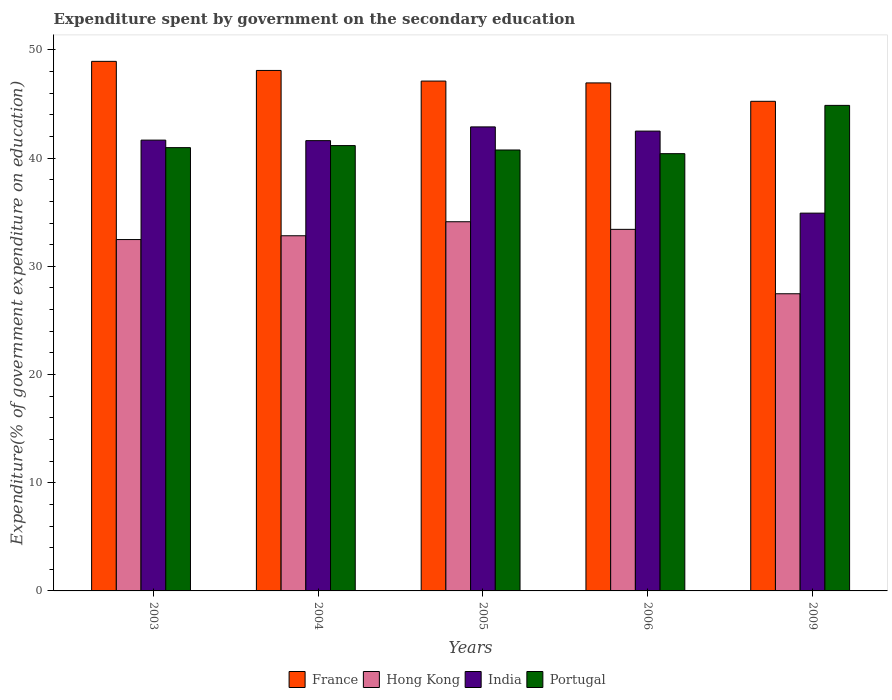Are the number of bars on each tick of the X-axis equal?
Your answer should be very brief. Yes. How many bars are there on the 5th tick from the right?
Your answer should be compact. 4. What is the expenditure spent by government on the secondary education in India in 2009?
Provide a succinct answer. 34.92. Across all years, what is the maximum expenditure spent by government on the secondary education in France?
Offer a very short reply. 48.95. Across all years, what is the minimum expenditure spent by government on the secondary education in India?
Provide a short and direct response. 34.92. In which year was the expenditure spent by government on the secondary education in Hong Kong minimum?
Provide a succinct answer. 2009. What is the total expenditure spent by government on the secondary education in France in the graph?
Your answer should be compact. 236.38. What is the difference between the expenditure spent by government on the secondary education in France in 2003 and that in 2004?
Keep it short and to the point. 0.84. What is the difference between the expenditure spent by government on the secondary education in France in 2003 and the expenditure spent by government on the secondary education in India in 2009?
Ensure brevity in your answer.  14.03. What is the average expenditure spent by government on the secondary education in Portugal per year?
Offer a terse response. 41.64. In the year 2006, what is the difference between the expenditure spent by government on the secondary education in Hong Kong and expenditure spent by government on the secondary education in Portugal?
Your answer should be very brief. -7. What is the ratio of the expenditure spent by government on the secondary education in Hong Kong in 2005 to that in 2006?
Your response must be concise. 1.02. Is the expenditure spent by government on the secondary education in France in 2005 less than that in 2009?
Offer a very short reply. No. Is the difference between the expenditure spent by government on the secondary education in Hong Kong in 2003 and 2005 greater than the difference between the expenditure spent by government on the secondary education in Portugal in 2003 and 2005?
Make the answer very short. No. What is the difference between the highest and the second highest expenditure spent by government on the secondary education in Hong Kong?
Ensure brevity in your answer.  0.7. What is the difference between the highest and the lowest expenditure spent by government on the secondary education in India?
Give a very brief answer. 7.97. What does the 2nd bar from the left in 2004 represents?
Provide a short and direct response. Hong Kong. What does the 3rd bar from the right in 2006 represents?
Ensure brevity in your answer.  Hong Kong. How many bars are there?
Make the answer very short. 20. Are all the bars in the graph horizontal?
Your response must be concise. No. Does the graph contain any zero values?
Ensure brevity in your answer.  No. Does the graph contain grids?
Provide a short and direct response. No. How are the legend labels stacked?
Make the answer very short. Horizontal. What is the title of the graph?
Your response must be concise. Expenditure spent by government on the secondary education. Does "South Sudan" appear as one of the legend labels in the graph?
Make the answer very short. No. What is the label or title of the X-axis?
Provide a succinct answer. Years. What is the label or title of the Y-axis?
Provide a short and direct response. Expenditure(% of government expenditure on education). What is the Expenditure(% of government expenditure on education) in France in 2003?
Make the answer very short. 48.95. What is the Expenditure(% of government expenditure on education) of Hong Kong in 2003?
Your answer should be compact. 32.48. What is the Expenditure(% of government expenditure on education) in India in 2003?
Offer a terse response. 41.67. What is the Expenditure(% of government expenditure on education) of Portugal in 2003?
Your response must be concise. 40.97. What is the Expenditure(% of government expenditure on education) in France in 2004?
Give a very brief answer. 48.11. What is the Expenditure(% of government expenditure on education) in Hong Kong in 2004?
Give a very brief answer. 32.83. What is the Expenditure(% of government expenditure on education) of India in 2004?
Your response must be concise. 41.62. What is the Expenditure(% of government expenditure on education) in Portugal in 2004?
Your answer should be compact. 41.16. What is the Expenditure(% of government expenditure on education) in France in 2005?
Your response must be concise. 47.12. What is the Expenditure(% of government expenditure on education) of Hong Kong in 2005?
Offer a very short reply. 34.12. What is the Expenditure(% of government expenditure on education) in India in 2005?
Ensure brevity in your answer.  42.89. What is the Expenditure(% of government expenditure on education) of Portugal in 2005?
Provide a short and direct response. 40.75. What is the Expenditure(% of government expenditure on education) of France in 2006?
Make the answer very short. 46.95. What is the Expenditure(% of government expenditure on education) of Hong Kong in 2006?
Your answer should be very brief. 33.42. What is the Expenditure(% of government expenditure on education) in India in 2006?
Make the answer very short. 42.5. What is the Expenditure(% of government expenditure on education) of Portugal in 2006?
Your response must be concise. 40.41. What is the Expenditure(% of government expenditure on education) in France in 2009?
Provide a succinct answer. 45.25. What is the Expenditure(% of government expenditure on education) in Hong Kong in 2009?
Offer a terse response. 27.47. What is the Expenditure(% of government expenditure on education) in India in 2009?
Provide a succinct answer. 34.92. What is the Expenditure(% of government expenditure on education) of Portugal in 2009?
Offer a terse response. 44.88. Across all years, what is the maximum Expenditure(% of government expenditure on education) of France?
Provide a short and direct response. 48.95. Across all years, what is the maximum Expenditure(% of government expenditure on education) of Hong Kong?
Your answer should be compact. 34.12. Across all years, what is the maximum Expenditure(% of government expenditure on education) in India?
Your answer should be very brief. 42.89. Across all years, what is the maximum Expenditure(% of government expenditure on education) of Portugal?
Give a very brief answer. 44.88. Across all years, what is the minimum Expenditure(% of government expenditure on education) of France?
Make the answer very short. 45.25. Across all years, what is the minimum Expenditure(% of government expenditure on education) of Hong Kong?
Make the answer very short. 27.47. Across all years, what is the minimum Expenditure(% of government expenditure on education) in India?
Ensure brevity in your answer.  34.92. Across all years, what is the minimum Expenditure(% of government expenditure on education) in Portugal?
Your answer should be compact. 40.41. What is the total Expenditure(% of government expenditure on education) of France in the graph?
Your response must be concise. 236.38. What is the total Expenditure(% of government expenditure on education) in Hong Kong in the graph?
Ensure brevity in your answer.  160.31. What is the total Expenditure(% of government expenditure on education) in India in the graph?
Provide a succinct answer. 203.59. What is the total Expenditure(% of government expenditure on education) in Portugal in the graph?
Give a very brief answer. 208.18. What is the difference between the Expenditure(% of government expenditure on education) of France in 2003 and that in 2004?
Offer a very short reply. 0.84. What is the difference between the Expenditure(% of government expenditure on education) of Hong Kong in 2003 and that in 2004?
Ensure brevity in your answer.  -0.35. What is the difference between the Expenditure(% of government expenditure on education) in India in 2003 and that in 2004?
Your answer should be compact. 0.05. What is the difference between the Expenditure(% of government expenditure on education) in Portugal in 2003 and that in 2004?
Offer a very short reply. -0.19. What is the difference between the Expenditure(% of government expenditure on education) of France in 2003 and that in 2005?
Give a very brief answer. 1.82. What is the difference between the Expenditure(% of government expenditure on education) in Hong Kong in 2003 and that in 2005?
Your response must be concise. -1.65. What is the difference between the Expenditure(% of government expenditure on education) of India in 2003 and that in 2005?
Make the answer very short. -1.22. What is the difference between the Expenditure(% of government expenditure on education) of Portugal in 2003 and that in 2005?
Your answer should be very brief. 0.22. What is the difference between the Expenditure(% of government expenditure on education) of France in 2003 and that in 2006?
Your answer should be very brief. 1.99. What is the difference between the Expenditure(% of government expenditure on education) in Hong Kong in 2003 and that in 2006?
Offer a terse response. -0.94. What is the difference between the Expenditure(% of government expenditure on education) of India in 2003 and that in 2006?
Make the answer very short. -0.83. What is the difference between the Expenditure(% of government expenditure on education) of Portugal in 2003 and that in 2006?
Give a very brief answer. 0.56. What is the difference between the Expenditure(% of government expenditure on education) of France in 2003 and that in 2009?
Give a very brief answer. 3.69. What is the difference between the Expenditure(% of government expenditure on education) of Hong Kong in 2003 and that in 2009?
Offer a terse response. 5.01. What is the difference between the Expenditure(% of government expenditure on education) in India in 2003 and that in 2009?
Provide a short and direct response. 6.75. What is the difference between the Expenditure(% of government expenditure on education) in Portugal in 2003 and that in 2009?
Provide a short and direct response. -3.91. What is the difference between the Expenditure(% of government expenditure on education) in France in 2004 and that in 2005?
Your answer should be very brief. 0.98. What is the difference between the Expenditure(% of government expenditure on education) of Hong Kong in 2004 and that in 2005?
Offer a terse response. -1.3. What is the difference between the Expenditure(% of government expenditure on education) of India in 2004 and that in 2005?
Give a very brief answer. -1.27. What is the difference between the Expenditure(% of government expenditure on education) in Portugal in 2004 and that in 2005?
Provide a succinct answer. 0.41. What is the difference between the Expenditure(% of government expenditure on education) in France in 2004 and that in 2006?
Offer a very short reply. 1.15. What is the difference between the Expenditure(% of government expenditure on education) of Hong Kong in 2004 and that in 2006?
Give a very brief answer. -0.59. What is the difference between the Expenditure(% of government expenditure on education) in India in 2004 and that in 2006?
Offer a very short reply. -0.88. What is the difference between the Expenditure(% of government expenditure on education) of Portugal in 2004 and that in 2006?
Your response must be concise. 0.75. What is the difference between the Expenditure(% of government expenditure on education) of France in 2004 and that in 2009?
Keep it short and to the point. 2.85. What is the difference between the Expenditure(% of government expenditure on education) in Hong Kong in 2004 and that in 2009?
Ensure brevity in your answer.  5.36. What is the difference between the Expenditure(% of government expenditure on education) in India in 2004 and that in 2009?
Provide a succinct answer. 6.7. What is the difference between the Expenditure(% of government expenditure on education) in Portugal in 2004 and that in 2009?
Your answer should be compact. -3.72. What is the difference between the Expenditure(% of government expenditure on education) in France in 2005 and that in 2006?
Give a very brief answer. 0.17. What is the difference between the Expenditure(% of government expenditure on education) in Hong Kong in 2005 and that in 2006?
Ensure brevity in your answer.  0.7. What is the difference between the Expenditure(% of government expenditure on education) in India in 2005 and that in 2006?
Offer a very short reply. 0.39. What is the difference between the Expenditure(% of government expenditure on education) in Portugal in 2005 and that in 2006?
Offer a very short reply. 0.34. What is the difference between the Expenditure(% of government expenditure on education) of France in 2005 and that in 2009?
Offer a very short reply. 1.87. What is the difference between the Expenditure(% of government expenditure on education) in Hong Kong in 2005 and that in 2009?
Give a very brief answer. 6.66. What is the difference between the Expenditure(% of government expenditure on education) of India in 2005 and that in 2009?
Your answer should be compact. 7.97. What is the difference between the Expenditure(% of government expenditure on education) of Portugal in 2005 and that in 2009?
Keep it short and to the point. -4.12. What is the difference between the Expenditure(% of government expenditure on education) of France in 2006 and that in 2009?
Offer a terse response. 1.7. What is the difference between the Expenditure(% of government expenditure on education) of Hong Kong in 2006 and that in 2009?
Provide a succinct answer. 5.95. What is the difference between the Expenditure(% of government expenditure on education) in India in 2006 and that in 2009?
Your response must be concise. 7.58. What is the difference between the Expenditure(% of government expenditure on education) in Portugal in 2006 and that in 2009?
Give a very brief answer. -4.46. What is the difference between the Expenditure(% of government expenditure on education) in France in 2003 and the Expenditure(% of government expenditure on education) in Hong Kong in 2004?
Your answer should be very brief. 16.12. What is the difference between the Expenditure(% of government expenditure on education) of France in 2003 and the Expenditure(% of government expenditure on education) of India in 2004?
Give a very brief answer. 7.33. What is the difference between the Expenditure(% of government expenditure on education) of France in 2003 and the Expenditure(% of government expenditure on education) of Portugal in 2004?
Ensure brevity in your answer.  7.79. What is the difference between the Expenditure(% of government expenditure on education) of Hong Kong in 2003 and the Expenditure(% of government expenditure on education) of India in 2004?
Your answer should be compact. -9.14. What is the difference between the Expenditure(% of government expenditure on education) of Hong Kong in 2003 and the Expenditure(% of government expenditure on education) of Portugal in 2004?
Offer a very short reply. -8.69. What is the difference between the Expenditure(% of government expenditure on education) in India in 2003 and the Expenditure(% of government expenditure on education) in Portugal in 2004?
Keep it short and to the point. 0.5. What is the difference between the Expenditure(% of government expenditure on education) in France in 2003 and the Expenditure(% of government expenditure on education) in Hong Kong in 2005?
Make the answer very short. 14.82. What is the difference between the Expenditure(% of government expenditure on education) of France in 2003 and the Expenditure(% of government expenditure on education) of India in 2005?
Offer a terse response. 6.06. What is the difference between the Expenditure(% of government expenditure on education) of France in 2003 and the Expenditure(% of government expenditure on education) of Portugal in 2005?
Provide a short and direct response. 8.19. What is the difference between the Expenditure(% of government expenditure on education) in Hong Kong in 2003 and the Expenditure(% of government expenditure on education) in India in 2005?
Keep it short and to the point. -10.41. What is the difference between the Expenditure(% of government expenditure on education) of Hong Kong in 2003 and the Expenditure(% of government expenditure on education) of Portugal in 2005?
Provide a short and direct response. -8.28. What is the difference between the Expenditure(% of government expenditure on education) in India in 2003 and the Expenditure(% of government expenditure on education) in Portugal in 2005?
Provide a short and direct response. 0.91. What is the difference between the Expenditure(% of government expenditure on education) in France in 2003 and the Expenditure(% of government expenditure on education) in Hong Kong in 2006?
Provide a succinct answer. 15.53. What is the difference between the Expenditure(% of government expenditure on education) of France in 2003 and the Expenditure(% of government expenditure on education) of India in 2006?
Provide a short and direct response. 6.45. What is the difference between the Expenditure(% of government expenditure on education) of France in 2003 and the Expenditure(% of government expenditure on education) of Portugal in 2006?
Your answer should be compact. 8.53. What is the difference between the Expenditure(% of government expenditure on education) in Hong Kong in 2003 and the Expenditure(% of government expenditure on education) in India in 2006?
Your response must be concise. -10.02. What is the difference between the Expenditure(% of government expenditure on education) in Hong Kong in 2003 and the Expenditure(% of government expenditure on education) in Portugal in 2006?
Make the answer very short. -7.94. What is the difference between the Expenditure(% of government expenditure on education) in India in 2003 and the Expenditure(% of government expenditure on education) in Portugal in 2006?
Your response must be concise. 1.25. What is the difference between the Expenditure(% of government expenditure on education) in France in 2003 and the Expenditure(% of government expenditure on education) in Hong Kong in 2009?
Make the answer very short. 21.48. What is the difference between the Expenditure(% of government expenditure on education) in France in 2003 and the Expenditure(% of government expenditure on education) in India in 2009?
Ensure brevity in your answer.  14.03. What is the difference between the Expenditure(% of government expenditure on education) in France in 2003 and the Expenditure(% of government expenditure on education) in Portugal in 2009?
Your answer should be compact. 4.07. What is the difference between the Expenditure(% of government expenditure on education) in Hong Kong in 2003 and the Expenditure(% of government expenditure on education) in India in 2009?
Give a very brief answer. -2.44. What is the difference between the Expenditure(% of government expenditure on education) of Hong Kong in 2003 and the Expenditure(% of government expenditure on education) of Portugal in 2009?
Make the answer very short. -12.4. What is the difference between the Expenditure(% of government expenditure on education) in India in 2003 and the Expenditure(% of government expenditure on education) in Portugal in 2009?
Your answer should be compact. -3.21. What is the difference between the Expenditure(% of government expenditure on education) of France in 2004 and the Expenditure(% of government expenditure on education) of Hong Kong in 2005?
Provide a succinct answer. 13.98. What is the difference between the Expenditure(% of government expenditure on education) of France in 2004 and the Expenditure(% of government expenditure on education) of India in 2005?
Provide a succinct answer. 5.22. What is the difference between the Expenditure(% of government expenditure on education) in France in 2004 and the Expenditure(% of government expenditure on education) in Portugal in 2005?
Offer a very short reply. 7.35. What is the difference between the Expenditure(% of government expenditure on education) of Hong Kong in 2004 and the Expenditure(% of government expenditure on education) of India in 2005?
Keep it short and to the point. -10.06. What is the difference between the Expenditure(% of government expenditure on education) in Hong Kong in 2004 and the Expenditure(% of government expenditure on education) in Portugal in 2005?
Ensure brevity in your answer.  -7.93. What is the difference between the Expenditure(% of government expenditure on education) of India in 2004 and the Expenditure(% of government expenditure on education) of Portugal in 2005?
Offer a very short reply. 0.87. What is the difference between the Expenditure(% of government expenditure on education) of France in 2004 and the Expenditure(% of government expenditure on education) of Hong Kong in 2006?
Provide a succinct answer. 14.69. What is the difference between the Expenditure(% of government expenditure on education) of France in 2004 and the Expenditure(% of government expenditure on education) of India in 2006?
Provide a succinct answer. 5.61. What is the difference between the Expenditure(% of government expenditure on education) of France in 2004 and the Expenditure(% of government expenditure on education) of Portugal in 2006?
Provide a succinct answer. 7.69. What is the difference between the Expenditure(% of government expenditure on education) of Hong Kong in 2004 and the Expenditure(% of government expenditure on education) of India in 2006?
Offer a very short reply. -9.67. What is the difference between the Expenditure(% of government expenditure on education) of Hong Kong in 2004 and the Expenditure(% of government expenditure on education) of Portugal in 2006?
Ensure brevity in your answer.  -7.59. What is the difference between the Expenditure(% of government expenditure on education) of India in 2004 and the Expenditure(% of government expenditure on education) of Portugal in 2006?
Your response must be concise. 1.2. What is the difference between the Expenditure(% of government expenditure on education) of France in 2004 and the Expenditure(% of government expenditure on education) of Hong Kong in 2009?
Your answer should be compact. 20.64. What is the difference between the Expenditure(% of government expenditure on education) of France in 2004 and the Expenditure(% of government expenditure on education) of India in 2009?
Your answer should be very brief. 13.19. What is the difference between the Expenditure(% of government expenditure on education) of France in 2004 and the Expenditure(% of government expenditure on education) of Portugal in 2009?
Make the answer very short. 3.23. What is the difference between the Expenditure(% of government expenditure on education) of Hong Kong in 2004 and the Expenditure(% of government expenditure on education) of India in 2009?
Your answer should be compact. -2.09. What is the difference between the Expenditure(% of government expenditure on education) of Hong Kong in 2004 and the Expenditure(% of government expenditure on education) of Portugal in 2009?
Your response must be concise. -12.05. What is the difference between the Expenditure(% of government expenditure on education) in India in 2004 and the Expenditure(% of government expenditure on education) in Portugal in 2009?
Offer a terse response. -3.26. What is the difference between the Expenditure(% of government expenditure on education) of France in 2005 and the Expenditure(% of government expenditure on education) of Hong Kong in 2006?
Ensure brevity in your answer.  13.71. What is the difference between the Expenditure(% of government expenditure on education) of France in 2005 and the Expenditure(% of government expenditure on education) of India in 2006?
Give a very brief answer. 4.62. What is the difference between the Expenditure(% of government expenditure on education) in France in 2005 and the Expenditure(% of government expenditure on education) in Portugal in 2006?
Your answer should be very brief. 6.71. What is the difference between the Expenditure(% of government expenditure on education) in Hong Kong in 2005 and the Expenditure(% of government expenditure on education) in India in 2006?
Your answer should be very brief. -8.38. What is the difference between the Expenditure(% of government expenditure on education) in Hong Kong in 2005 and the Expenditure(% of government expenditure on education) in Portugal in 2006?
Ensure brevity in your answer.  -6.29. What is the difference between the Expenditure(% of government expenditure on education) in India in 2005 and the Expenditure(% of government expenditure on education) in Portugal in 2006?
Keep it short and to the point. 2.47. What is the difference between the Expenditure(% of government expenditure on education) in France in 2005 and the Expenditure(% of government expenditure on education) in Hong Kong in 2009?
Your response must be concise. 19.66. What is the difference between the Expenditure(% of government expenditure on education) in France in 2005 and the Expenditure(% of government expenditure on education) in India in 2009?
Offer a terse response. 12.21. What is the difference between the Expenditure(% of government expenditure on education) of France in 2005 and the Expenditure(% of government expenditure on education) of Portugal in 2009?
Provide a short and direct response. 2.25. What is the difference between the Expenditure(% of government expenditure on education) in Hong Kong in 2005 and the Expenditure(% of government expenditure on education) in India in 2009?
Provide a succinct answer. -0.8. What is the difference between the Expenditure(% of government expenditure on education) of Hong Kong in 2005 and the Expenditure(% of government expenditure on education) of Portugal in 2009?
Provide a short and direct response. -10.75. What is the difference between the Expenditure(% of government expenditure on education) in India in 2005 and the Expenditure(% of government expenditure on education) in Portugal in 2009?
Ensure brevity in your answer.  -1.99. What is the difference between the Expenditure(% of government expenditure on education) of France in 2006 and the Expenditure(% of government expenditure on education) of Hong Kong in 2009?
Provide a succinct answer. 19.49. What is the difference between the Expenditure(% of government expenditure on education) in France in 2006 and the Expenditure(% of government expenditure on education) in India in 2009?
Provide a succinct answer. 12.04. What is the difference between the Expenditure(% of government expenditure on education) of France in 2006 and the Expenditure(% of government expenditure on education) of Portugal in 2009?
Your response must be concise. 2.08. What is the difference between the Expenditure(% of government expenditure on education) of Hong Kong in 2006 and the Expenditure(% of government expenditure on education) of India in 2009?
Provide a succinct answer. -1.5. What is the difference between the Expenditure(% of government expenditure on education) of Hong Kong in 2006 and the Expenditure(% of government expenditure on education) of Portugal in 2009?
Ensure brevity in your answer.  -11.46. What is the difference between the Expenditure(% of government expenditure on education) in India in 2006 and the Expenditure(% of government expenditure on education) in Portugal in 2009?
Provide a succinct answer. -2.38. What is the average Expenditure(% of government expenditure on education) in France per year?
Ensure brevity in your answer.  47.28. What is the average Expenditure(% of government expenditure on education) of Hong Kong per year?
Provide a succinct answer. 32.06. What is the average Expenditure(% of government expenditure on education) in India per year?
Your response must be concise. 40.72. What is the average Expenditure(% of government expenditure on education) of Portugal per year?
Offer a very short reply. 41.64. In the year 2003, what is the difference between the Expenditure(% of government expenditure on education) in France and Expenditure(% of government expenditure on education) in Hong Kong?
Offer a very short reply. 16.47. In the year 2003, what is the difference between the Expenditure(% of government expenditure on education) in France and Expenditure(% of government expenditure on education) in India?
Offer a terse response. 7.28. In the year 2003, what is the difference between the Expenditure(% of government expenditure on education) of France and Expenditure(% of government expenditure on education) of Portugal?
Provide a succinct answer. 7.97. In the year 2003, what is the difference between the Expenditure(% of government expenditure on education) in Hong Kong and Expenditure(% of government expenditure on education) in India?
Your response must be concise. -9.19. In the year 2003, what is the difference between the Expenditure(% of government expenditure on education) in Hong Kong and Expenditure(% of government expenditure on education) in Portugal?
Your answer should be compact. -8.5. In the year 2003, what is the difference between the Expenditure(% of government expenditure on education) in India and Expenditure(% of government expenditure on education) in Portugal?
Give a very brief answer. 0.69. In the year 2004, what is the difference between the Expenditure(% of government expenditure on education) of France and Expenditure(% of government expenditure on education) of Hong Kong?
Give a very brief answer. 15.28. In the year 2004, what is the difference between the Expenditure(% of government expenditure on education) of France and Expenditure(% of government expenditure on education) of India?
Keep it short and to the point. 6.49. In the year 2004, what is the difference between the Expenditure(% of government expenditure on education) in France and Expenditure(% of government expenditure on education) in Portugal?
Offer a terse response. 6.94. In the year 2004, what is the difference between the Expenditure(% of government expenditure on education) in Hong Kong and Expenditure(% of government expenditure on education) in India?
Provide a succinct answer. -8.79. In the year 2004, what is the difference between the Expenditure(% of government expenditure on education) of Hong Kong and Expenditure(% of government expenditure on education) of Portugal?
Offer a terse response. -8.33. In the year 2004, what is the difference between the Expenditure(% of government expenditure on education) in India and Expenditure(% of government expenditure on education) in Portugal?
Offer a very short reply. 0.46. In the year 2005, what is the difference between the Expenditure(% of government expenditure on education) of France and Expenditure(% of government expenditure on education) of Hong Kong?
Your response must be concise. 13. In the year 2005, what is the difference between the Expenditure(% of government expenditure on education) of France and Expenditure(% of government expenditure on education) of India?
Provide a short and direct response. 4.24. In the year 2005, what is the difference between the Expenditure(% of government expenditure on education) in France and Expenditure(% of government expenditure on education) in Portugal?
Provide a succinct answer. 6.37. In the year 2005, what is the difference between the Expenditure(% of government expenditure on education) of Hong Kong and Expenditure(% of government expenditure on education) of India?
Provide a short and direct response. -8.77. In the year 2005, what is the difference between the Expenditure(% of government expenditure on education) in Hong Kong and Expenditure(% of government expenditure on education) in Portugal?
Ensure brevity in your answer.  -6.63. In the year 2005, what is the difference between the Expenditure(% of government expenditure on education) of India and Expenditure(% of government expenditure on education) of Portugal?
Provide a succinct answer. 2.13. In the year 2006, what is the difference between the Expenditure(% of government expenditure on education) of France and Expenditure(% of government expenditure on education) of Hong Kong?
Offer a very short reply. 13.54. In the year 2006, what is the difference between the Expenditure(% of government expenditure on education) in France and Expenditure(% of government expenditure on education) in India?
Your answer should be very brief. 4.45. In the year 2006, what is the difference between the Expenditure(% of government expenditure on education) in France and Expenditure(% of government expenditure on education) in Portugal?
Your answer should be very brief. 6.54. In the year 2006, what is the difference between the Expenditure(% of government expenditure on education) of Hong Kong and Expenditure(% of government expenditure on education) of India?
Your answer should be very brief. -9.08. In the year 2006, what is the difference between the Expenditure(% of government expenditure on education) of Hong Kong and Expenditure(% of government expenditure on education) of Portugal?
Ensure brevity in your answer.  -7. In the year 2006, what is the difference between the Expenditure(% of government expenditure on education) of India and Expenditure(% of government expenditure on education) of Portugal?
Your answer should be compact. 2.09. In the year 2009, what is the difference between the Expenditure(% of government expenditure on education) in France and Expenditure(% of government expenditure on education) in Hong Kong?
Provide a succinct answer. 17.79. In the year 2009, what is the difference between the Expenditure(% of government expenditure on education) in France and Expenditure(% of government expenditure on education) in India?
Offer a terse response. 10.34. In the year 2009, what is the difference between the Expenditure(% of government expenditure on education) of France and Expenditure(% of government expenditure on education) of Portugal?
Offer a very short reply. 0.38. In the year 2009, what is the difference between the Expenditure(% of government expenditure on education) of Hong Kong and Expenditure(% of government expenditure on education) of India?
Offer a very short reply. -7.45. In the year 2009, what is the difference between the Expenditure(% of government expenditure on education) of Hong Kong and Expenditure(% of government expenditure on education) of Portugal?
Provide a succinct answer. -17.41. In the year 2009, what is the difference between the Expenditure(% of government expenditure on education) of India and Expenditure(% of government expenditure on education) of Portugal?
Provide a succinct answer. -9.96. What is the ratio of the Expenditure(% of government expenditure on education) of France in 2003 to that in 2004?
Offer a terse response. 1.02. What is the ratio of the Expenditure(% of government expenditure on education) of Hong Kong in 2003 to that in 2004?
Your response must be concise. 0.99. What is the ratio of the Expenditure(% of government expenditure on education) in India in 2003 to that in 2004?
Your response must be concise. 1. What is the ratio of the Expenditure(% of government expenditure on education) of Portugal in 2003 to that in 2004?
Ensure brevity in your answer.  1. What is the ratio of the Expenditure(% of government expenditure on education) in France in 2003 to that in 2005?
Keep it short and to the point. 1.04. What is the ratio of the Expenditure(% of government expenditure on education) of Hong Kong in 2003 to that in 2005?
Keep it short and to the point. 0.95. What is the ratio of the Expenditure(% of government expenditure on education) in India in 2003 to that in 2005?
Give a very brief answer. 0.97. What is the ratio of the Expenditure(% of government expenditure on education) of Portugal in 2003 to that in 2005?
Your response must be concise. 1.01. What is the ratio of the Expenditure(% of government expenditure on education) in France in 2003 to that in 2006?
Provide a succinct answer. 1.04. What is the ratio of the Expenditure(% of government expenditure on education) of Hong Kong in 2003 to that in 2006?
Keep it short and to the point. 0.97. What is the ratio of the Expenditure(% of government expenditure on education) in India in 2003 to that in 2006?
Keep it short and to the point. 0.98. What is the ratio of the Expenditure(% of government expenditure on education) in Portugal in 2003 to that in 2006?
Offer a very short reply. 1.01. What is the ratio of the Expenditure(% of government expenditure on education) of France in 2003 to that in 2009?
Keep it short and to the point. 1.08. What is the ratio of the Expenditure(% of government expenditure on education) in Hong Kong in 2003 to that in 2009?
Make the answer very short. 1.18. What is the ratio of the Expenditure(% of government expenditure on education) in India in 2003 to that in 2009?
Offer a very short reply. 1.19. What is the ratio of the Expenditure(% of government expenditure on education) of Portugal in 2003 to that in 2009?
Make the answer very short. 0.91. What is the ratio of the Expenditure(% of government expenditure on education) in France in 2004 to that in 2005?
Offer a terse response. 1.02. What is the ratio of the Expenditure(% of government expenditure on education) of Hong Kong in 2004 to that in 2005?
Offer a terse response. 0.96. What is the ratio of the Expenditure(% of government expenditure on education) in India in 2004 to that in 2005?
Keep it short and to the point. 0.97. What is the ratio of the Expenditure(% of government expenditure on education) of Portugal in 2004 to that in 2005?
Provide a short and direct response. 1.01. What is the ratio of the Expenditure(% of government expenditure on education) in France in 2004 to that in 2006?
Ensure brevity in your answer.  1.02. What is the ratio of the Expenditure(% of government expenditure on education) in Hong Kong in 2004 to that in 2006?
Keep it short and to the point. 0.98. What is the ratio of the Expenditure(% of government expenditure on education) of India in 2004 to that in 2006?
Give a very brief answer. 0.98. What is the ratio of the Expenditure(% of government expenditure on education) in Portugal in 2004 to that in 2006?
Provide a short and direct response. 1.02. What is the ratio of the Expenditure(% of government expenditure on education) in France in 2004 to that in 2009?
Provide a succinct answer. 1.06. What is the ratio of the Expenditure(% of government expenditure on education) in Hong Kong in 2004 to that in 2009?
Your response must be concise. 1.2. What is the ratio of the Expenditure(% of government expenditure on education) in India in 2004 to that in 2009?
Provide a short and direct response. 1.19. What is the ratio of the Expenditure(% of government expenditure on education) of Portugal in 2004 to that in 2009?
Offer a terse response. 0.92. What is the ratio of the Expenditure(% of government expenditure on education) in Hong Kong in 2005 to that in 2006?
Provide a succinct answer. 1.02. What is the ratio of the Expenditure(% of government expenditure on education) in India in 2005 to that in 2006?
Your answer should be very brief. 1.01. What is the ratio of the Expenditure(% of government expenditure on education) in Portugal in 2005 to that in 2006?
Give a very brief answer. 1.01. What is the ratio of the Expenditure(% of government expenditure on education) in France in 2005 to that in 2009?
Your response must be concise. 1.04. What is the ratio of the Expenditure(% of government expenditure on education) of Hong Kong in 2005 to that in 2009?
Provide a succinct answer. 1.24. What is the ratio of the Expenditure(% of government expenditure on education) in India in 2005 to that in 2009?
Make the answer very short. 1.23. What is the ratio of the Expenditure(% of government expenditure on education) in Portugal in 2005 to that in 2009?
Offer a terse response. 0.91. What is the ratio of the Expenditure(% of government expenditure on education) of France in 2006 to that in 2009?
Keep it short and to the point. 1.04. What is the ratio of the Expenditure(% of government expenditure on education) in Hong Kong in 2006 to that in 2009?
Make the answer very short. 1.22. What is the ratio of the Expenditure(% of government expenditure on education) of India in 2006 to that in 2009?
Keep it short and to the point. 1.22. What is the ratio of the Expenditure(% of government expenditure on education) of Portugal in 2006 to that in 2009?
Provide a succinct answer. 0.9. What is the difference between the highest and the second highest Expenditure(% of government expenditure on education) of France?
Keep it short and to the point. 0.84. What is the difference between the highest and the second highest Expenditure(% of government expenditure on education) in Hong Kong?
Your response must be concise. 0.7. What is the difference between the highest and the second highest Expenditure(% of government expenditure on education) in India?
Ensure brevity in your answer.  0.39. What is the difference between the highest and the second highest Expenditure(% of government expenditure on education) in Portugal?
Offer a very short reply. 3.72. What is the difference between the highest and the lowest Expenditure(% of government expenditure on education) in France?
Make the answer very short. 3.69. What is the difference between the highest and the lowest Expenditure(% of government expenditure on education) of Hong Kong?
Make the answer very short. 6.66. What is the difference between the highest and the lowest Expenditure(% of government expenditure on education) in India?
Provide a short and direct response. 7.97. What is the difference between the highest and the lowest Expenditure(% of government expenditure on education) in Portugal?
Your answer should be very brief. 4.46. 